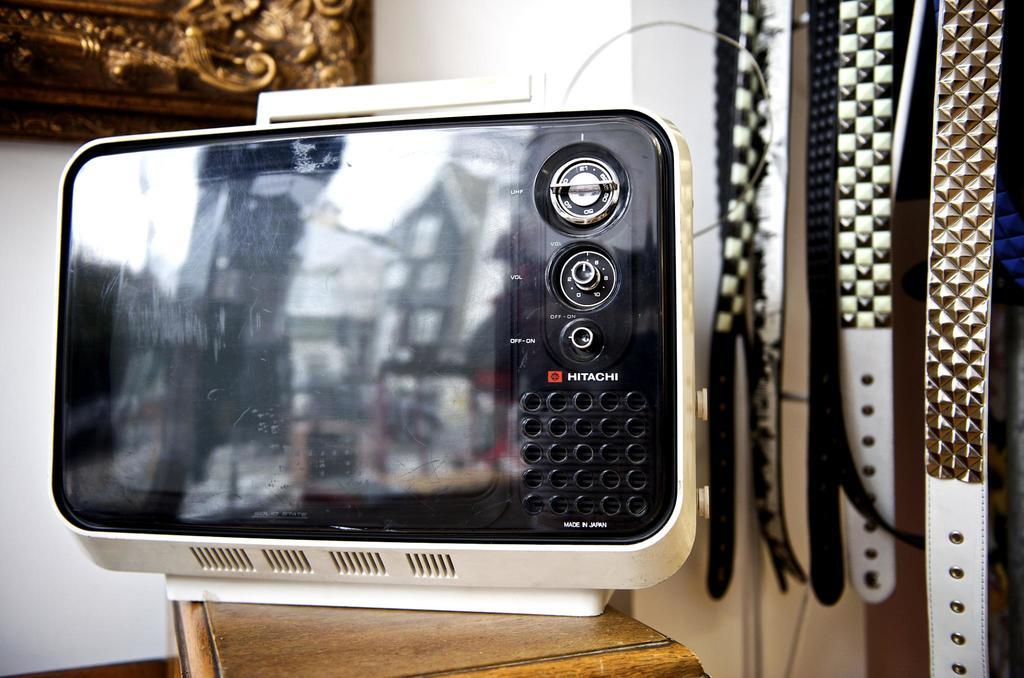Provide a one-sentence caption for the provided image. a Hitachi item that is on a brown surface. 